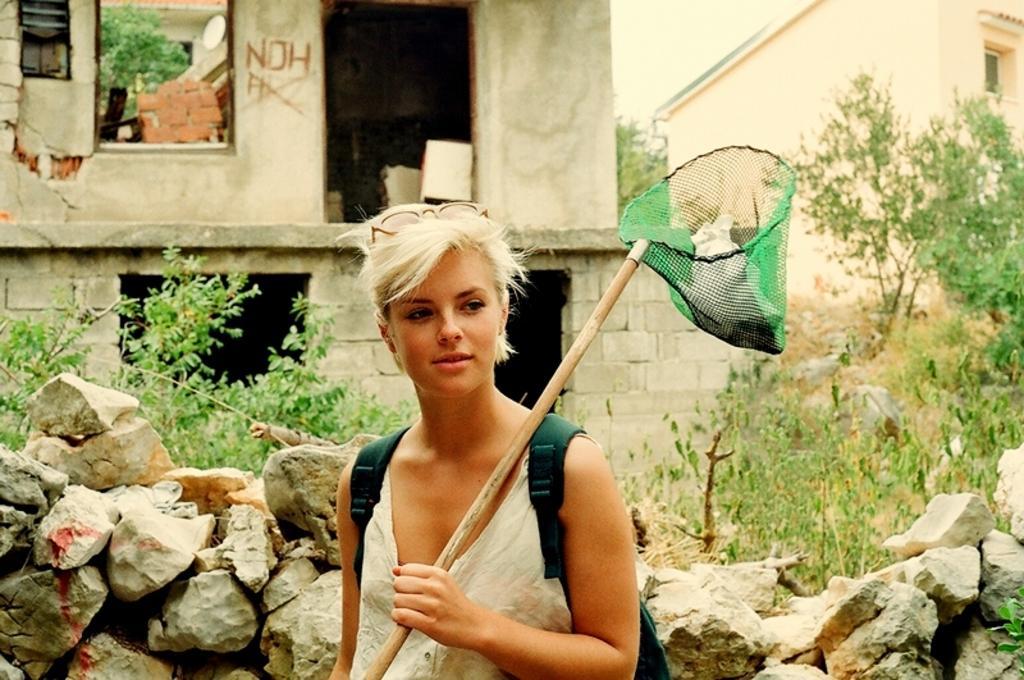How would you summarize this image in a sentence or two? In the middle of the image, there is a woman smiling, wearing a bag and holding a stick which is connected to a net. Beside her, there is a stone wall. In the background, there are plants, there are trees and there is sky. 